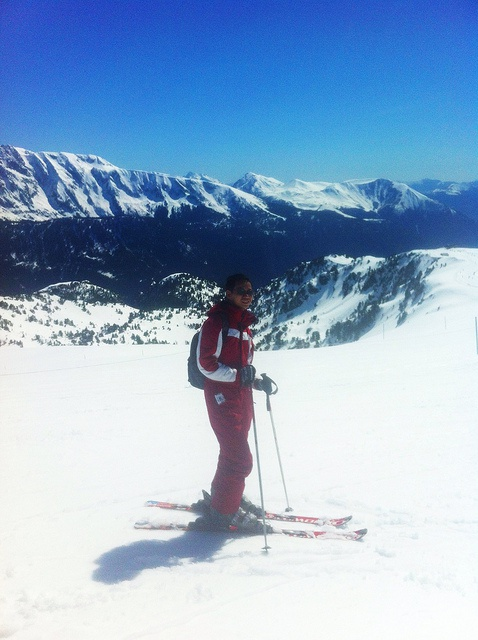Describe the objects in this image and their specific colors. I can see people in blue, gray, black, and purple tones, skis in blue, lightgray, darkgray, and lightpink tones, and backpack in blue, gray, black, and darkblue tones in this image. 